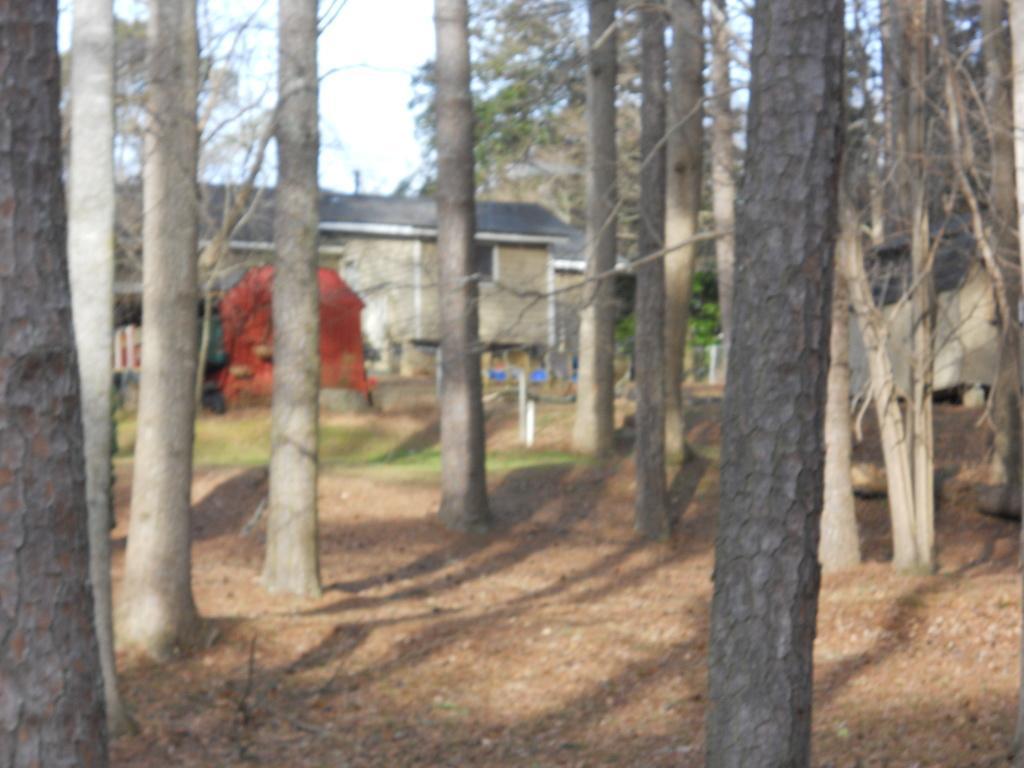Can you describe this image briefly? This is an outside view. In the foreground, I can see some trees on the ground. In the background there is a building. On the right side, I can see a wall. On the top of the image I can see the sky. 